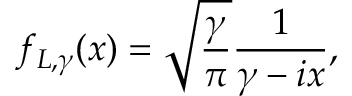Convert formula to latex. <formula><loc_0><loc_0><loc_500><loc_500>f _ { L , \gamma } ( x ) = \sqrt { \frac { \gamma } { \pi } } \frac { 1 } { \gamma - i x } ,</formula> 